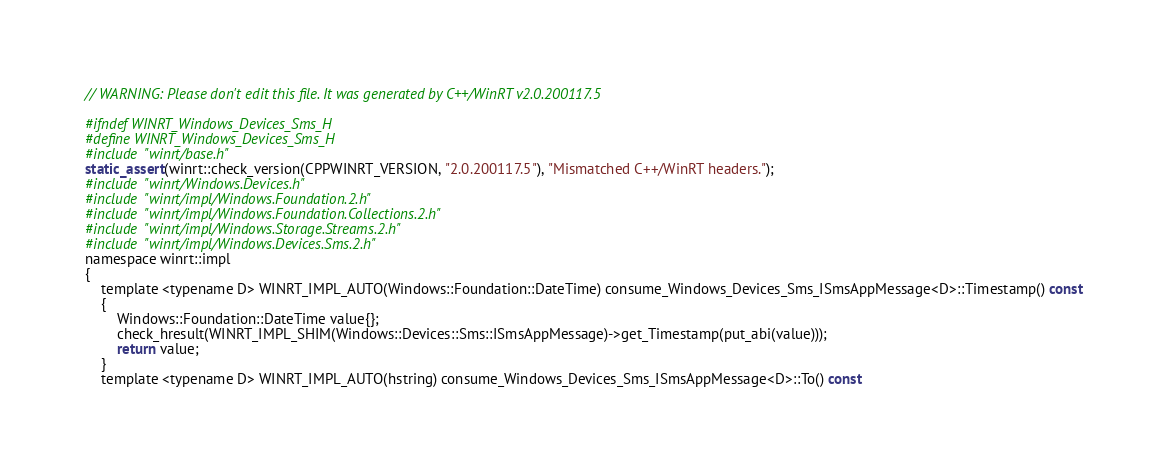<code> <loc_0><loc_0><loc_500><loc_500><_C_>// WARNING: Please don't edit this file. It was generated by C++/WinRT v2.0.200117.5

#ifndef WINRT_Windows_Devices_Sms_H
#define WINRT_Windows_Devices_Sms_H
#include "winrt/base.h"
static_assert(winrt::check_version(CPPWINRT_VERSION, "2.0.200117.5"), "Mismatched C++/WinRT headers.");
#include "winrt/Windows.Devices.h"
#include "winrt/impl/Windows.Foundation.2.h"
#include "winrt/impl/Windows.Foundation.Collections.2.h"
#include "winrt/impl/Windows.Storage.Streams.2.h"
#include "winrt/impl/Windows.Devices.Sms.2.h"
namespace winrt::impl
{
    template <typename D> WINRT_IMPL_AUTO(Windows::Foundation::DateTime) consume_Windows_Devices_Sms_ISmsAppMessage<D>::Timestamp() const
    {
        Windows::Foundation::DateTime value{};
        check_hresult(WINRT_IMPL_SHIM(Windows::Devices::Sms::ISmsAppMessage)->get_Timestamp(put_abi(value)));
        return value;
    }
    template <typename D> WINRT_IMPL_AUTO(hstring) consume_Windows_Devices_Sms_ISmsAppMessage<D>::To() const</code> 